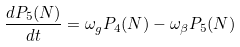Convert formula to latex. <formula><loc_0><loc_0><loc_500><loc_500>\frac { d P _ { 5 } ( N ) } { d t } = \omega _ { g } P _ { 4 } ( N ) - \omega _ { \beta } P _ { 5 } ( N )</formula> 